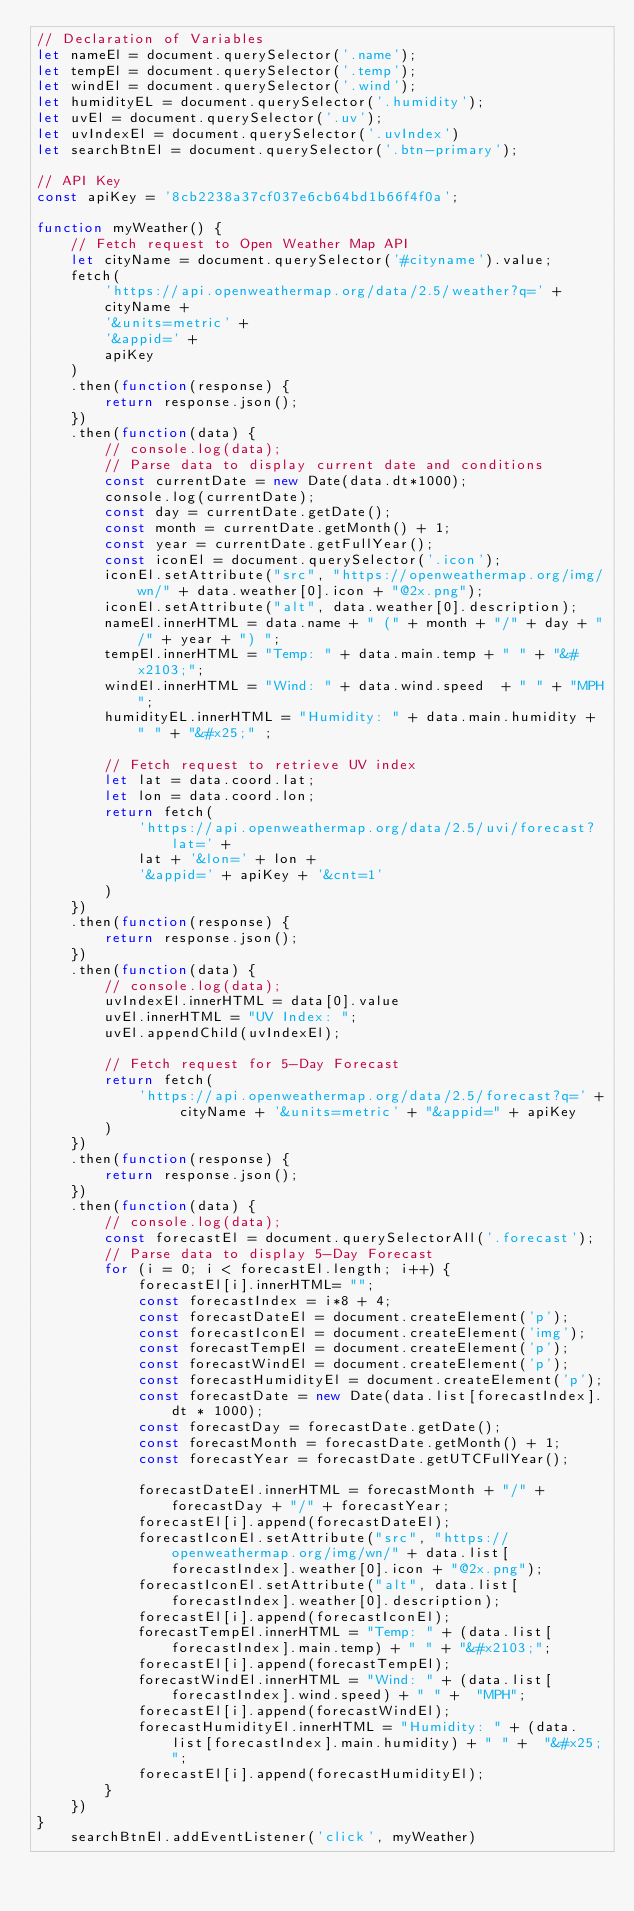Convert code to text. <code><loc_0><loc_0><loc_500><loc_500><_JavaScript_>// Declaration of Variables
let nameEl = document.querySelector('.name');
let tempEl = document.querySelector('.temp');
let windEl = document.querySelector('.wind');
let humidityEL = document.querySelector('.humidity');
let uvEl = document.querySelector('.uv');
let uvIndexEl = document.querySelector('.uvIndex')
let searchBtnEl = document.querySelector('.btn-primary');

// API Key
const apiKey = '8cb2238a37cf037e6cb64bd1b66f4f0a';

function myWeather() {
    // Fetch request to Open Weather Map API
    let cityName = document.querySelector('#cityname').value;
    fetch(
        'https://api.openweathermap.org/data/2.5/weather?q=' +
        cityName +
        '&units=metric' +
        '&appid=' +
        apiKey
    )
    .then(function(response) {
        return response.json();
    })
    .then(function(data) {
        // console.log(data);
        // Parse data to display current date and conditions
        const currentDate = new Date(data.dt*1000);
        console.log(currentDate);
        const day = currentDate.getDate();
        const month = currentDate.getMonth() + 1;
        const year = currentDate.getFullYear();
        const iconEl = document.querySelector('.icon');
        iconEl.setAttribute("src", "https://openweathermap.org/img/wn/" + data.weather[0].icon + "@2x.png");
        iconEl.setAttribute("alt", data.weather[0].description);
        nameEl.innerHTML = data.name + " (" + month + "/" + day + "/" + year + ") ";
        tempEl.innerHTML = "Temp: " + data.main.temp + " " + "&#x2103;";
        windEl.innerHTML = "Wind: " + data.wind.speed  + " " + "MPH";
        humidityEL.innerHTML = "Humidity: " + data.main.humidity + " " + "&#x25;" ;
        
        // Fetch request to retrieve UV index
        let lat = data.coord.lat;
        let lon = data.coord.lon;
        return fetch(
            'https://api.openweathermap.org/data/2.5/uvi/forecast?lat=' +
            lat + '&lon=' + lon +
            '&appid=' + apiKey + '&cnt=1'
        )
    })
    .then(function(response) {
        return response.json();
    })
    .then(function(data) {
        // console.log(data);
        uvIndexEl.innerHTML = data[0].value
        uvEl.innerHTML = "UV Index: ";
        uvEl.appendChild(uvIndexEl);

        // Fetch request for 5-Day Forecast
        return fetch(
            'https://api.openweathermap.org/data/2.5/forecast?q=' + cityName + '&units=metric' + "&appid=" + apiKey
        )
    })
    .then(function(response) {
        return response.json();
    })
    .then(function(data) {
        // console.log(data);
        const forecastEl = document.querySelectorAll('.forecast');
        // Parse data to display 5-Day Forecast
        for (i = 0; i < forecastEl.length; i++) {
            forecastEl[i].innerHTML= "";
            const forecastIndex = i*8 + 4;
            const forecastDateEl = document.createElement('p');
            const forecastIconEl = document.createElement('img');
            const forecastTempEl = document.createElement('p');
            const forecastWindEl = document.createElement('p');
            const forecastHumidityEl = document.createElement('p');
            const forecastDate = new Date(data.list[forecastIndex].dt * 1000);
            const forecastDay = forecastDate.getDate();
            const forecastMonth = forecastDate.getMonth() + 1;
            const forecastYear = forecastDate.getUTCFullYear();
            
            forecastDateEl.innerHTML = forecastMonth + "/" + forecastDay + "/" + forecastYear;
            forecastEl[i].append(forecastDateEl);
            forecastIconEl.setAttribute("src", "https://openweathermap.org/img/wn/" + data.list[forecastIndex].weather[0].icon + "@2x.png");
            forecastIconEl.setAttribute("alt", data.list[forecastIndex].weather[0].description);
            forecastEl[i].append(forecastIconEl);
            forecastTempEl.innerHTML = "Temp: " + (data.list[forecastIndex].main.temp) + " " + "&#x2103;";
            forecastEl[i].append(forecastTempEl);
            forecastWindEl.innerHTML = "Wind: " + (data.list[forecastIndex].wind.speed) + " " +  "MPH";
            forecastEl[i].append(forecastWindEl);
            forecastHumidityEl.innerHTML = "Humidity: " + (data.list[forecastIndex].main.humidity) + " " +  "&#x25;";
            forecastEl[i].append(forecastHumidityEl);
        }
    })
}
    searchBtnEl.addEventListener('click', myWeather)


    </code> 